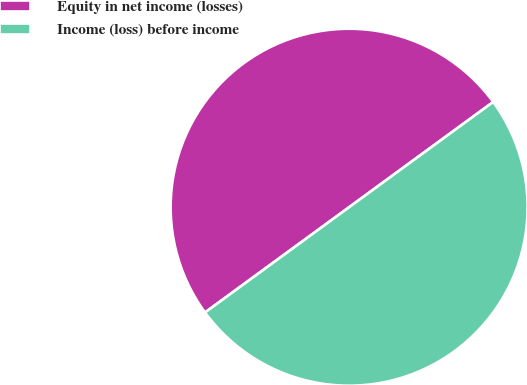Convert chart to OTSL. <chart><loc_0><loc_0><loc_500><loc_500><pie_chart><fcel>Equity in net income (losses)<fcel>Income (loss) before income<nl><fcel>50.0%<fcel>50.0%<nl></chart> 